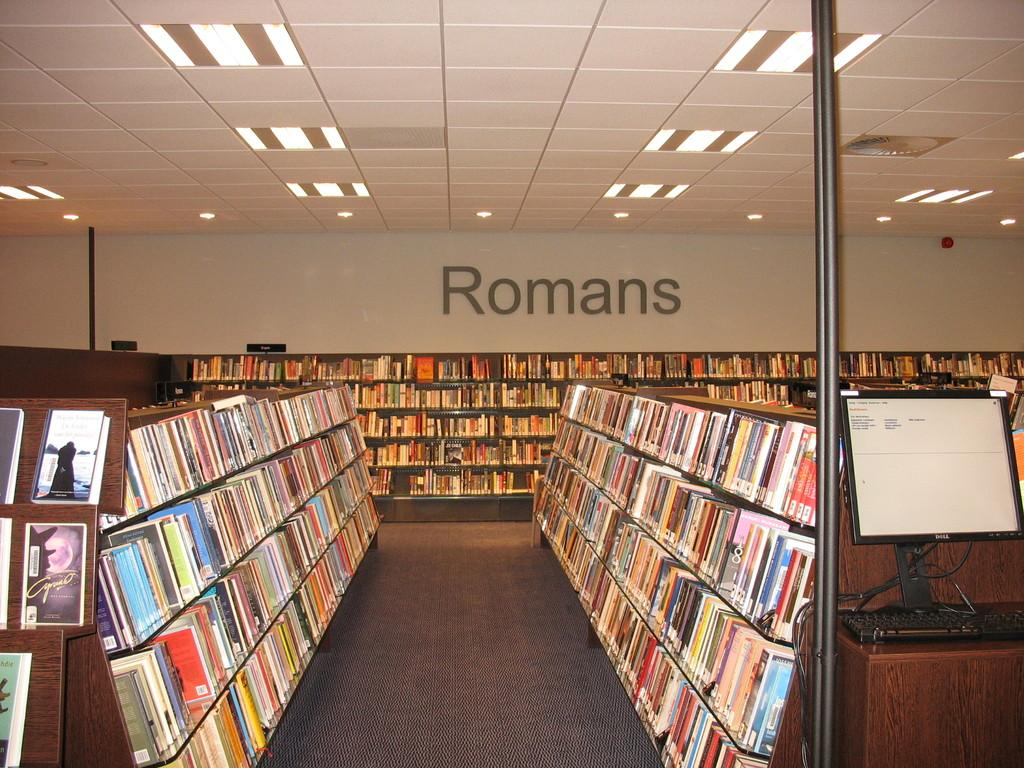<image>
Give a short and clear explanation of the subsequent image. A wall of bookshelves has the word Romans above them. 